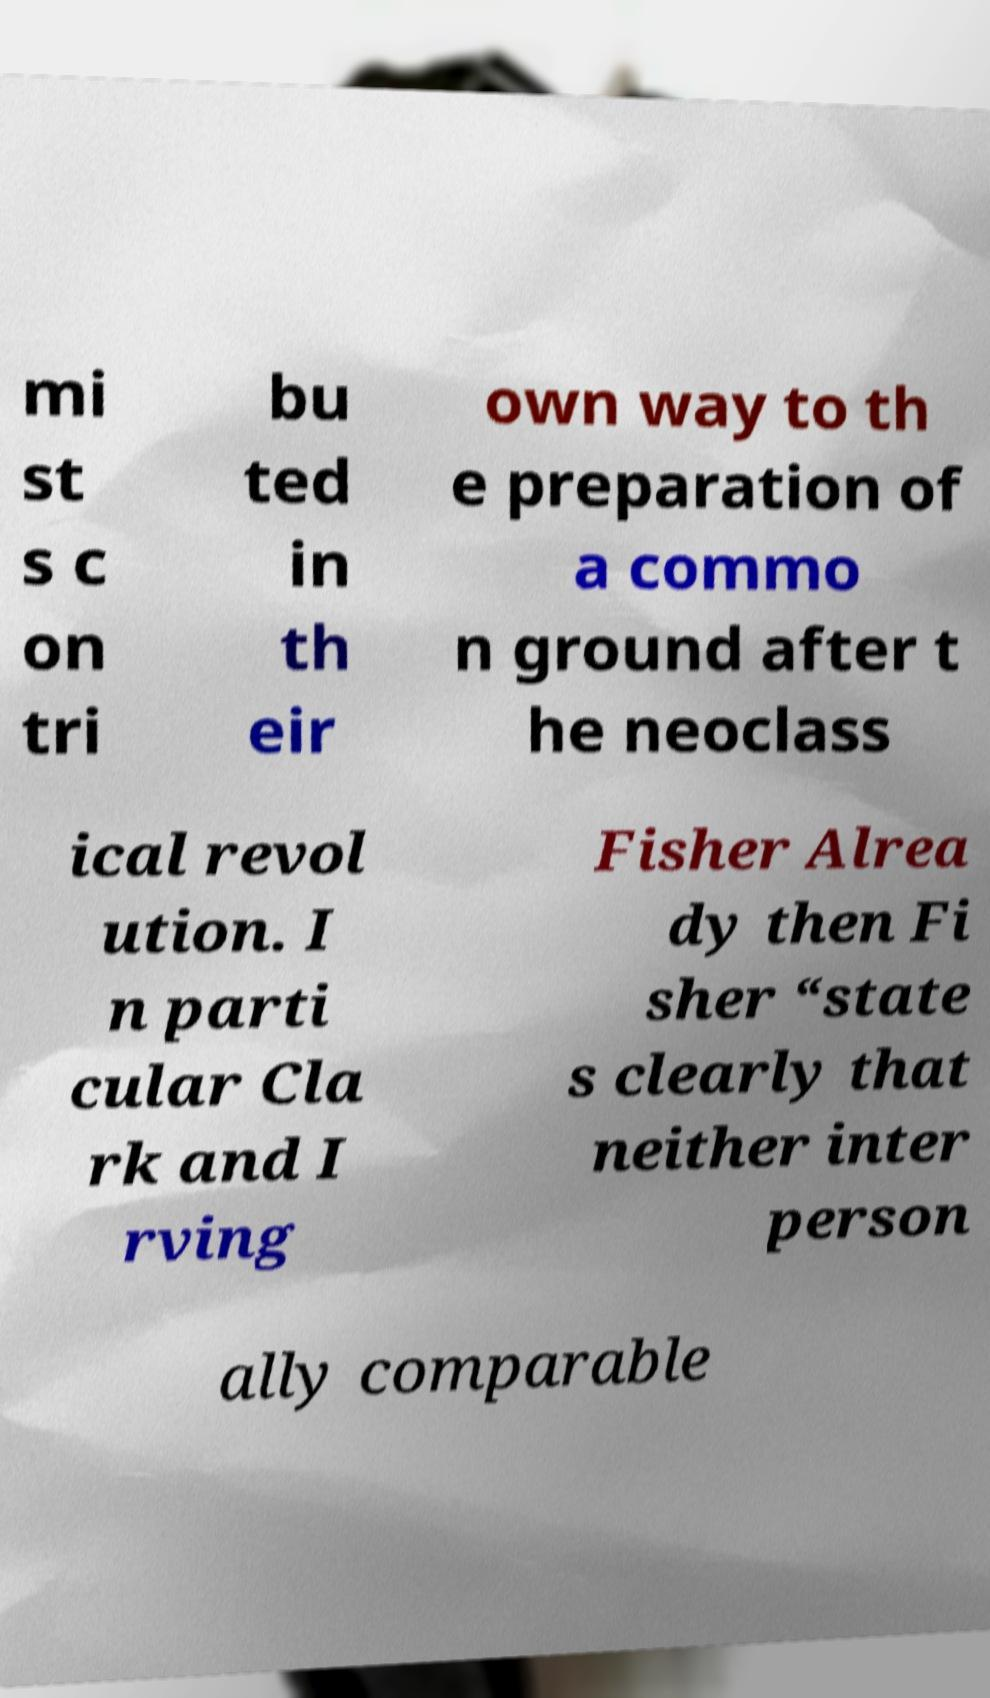Could you extract and type out the text from this image? mi st s c on tri bu ted in th eir own way to th e preparation of a commo n ground after t he neoclass ical revol ution. I n parti cular Cla rk and I rving Fisher Alrea dy then Fi sher “state s clearly that neither inter person ally comparable 